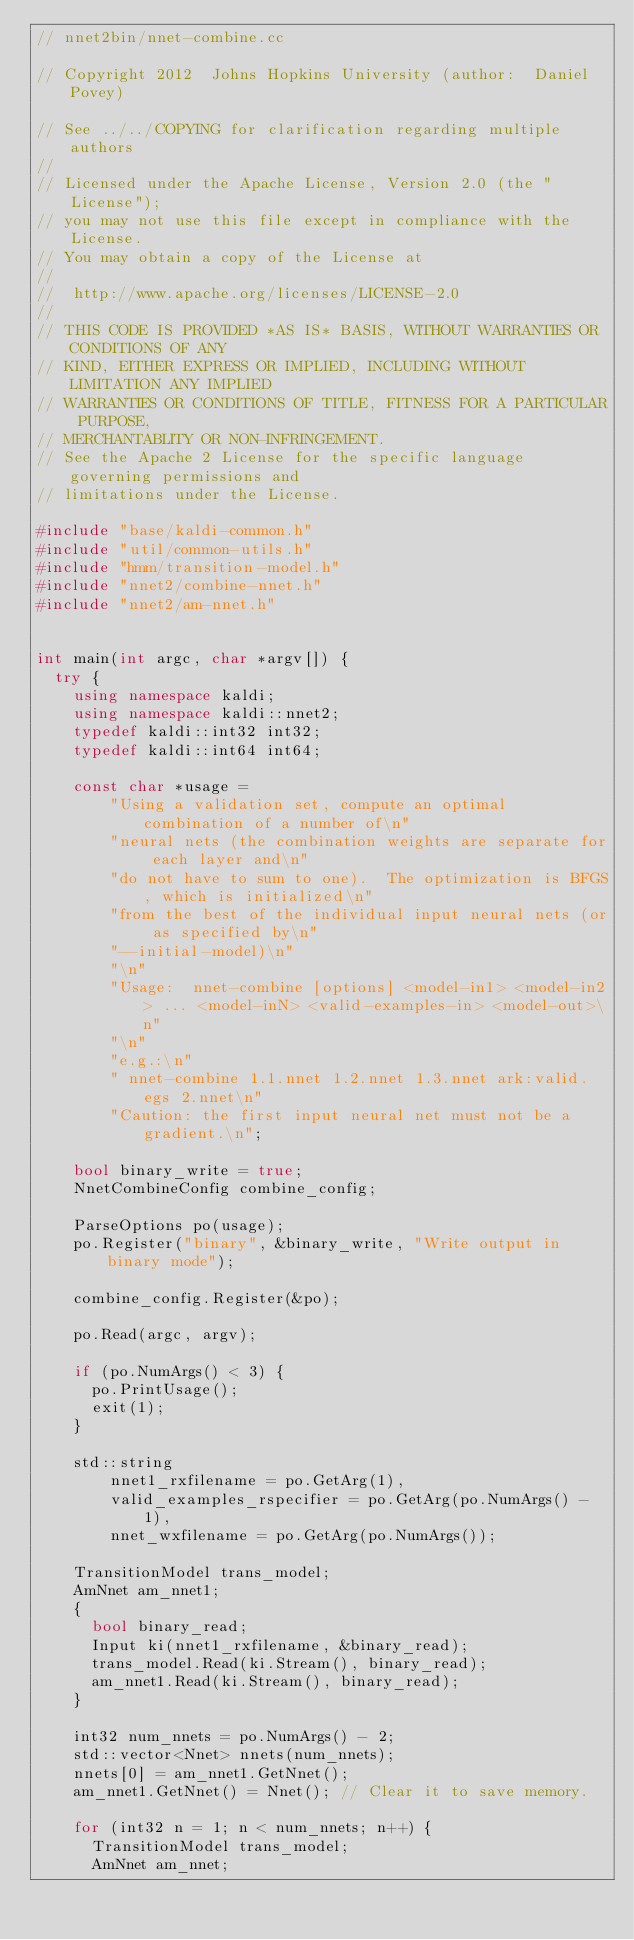Convert code to text. <code><loc_0><loc_0><loc_500><loc_500><_C++_>// nnet2bin/nnet-combine.cc

// Copyright 2012  Johns Hopkins University (author:  Daniel Povey)

// See ../../COPYING for clarification regarding multiple authors
//
// Licensed under the Apache License, Version 2.0 (the "License");
// you may not use this file except in compliance with the License.
// You may obtain a copy of the License at
//
//  http://www.apache.org/licenses/LICENSE-2.0
//
// THIS CODE IS PROVIDED *AS IS* BASIS, WITHOUT WARRANTIES OR CONDITIONS OF ANY
// KIND, EITHER EXPRESS OR IMPLIED, INCLUDING WITHOUT LIMITATION ANY IMPLIED
// WARRANTIES OR CONDITIONS OF TITLE, FITNESS FOR A PARTICULAR PURPOSE,
// MERCHANTABLITY OR NON-INFRINGEMENT.
// See the Apache 2 License for the specific language governing permissions and
// limitations under the License.

#include "base/kaldi-common.h"
#include "util/common-utils.h"
#include "hmm/transition-model.h"
#include "nnet2/combine-nnet.h"
#include "nnet2/am-nnet.h"


int main(int argc, char *argv[]) {
  try {
    using namespace kaldi;
    using namespace kaldi::nnet2;
    typedef kaldi::int32 int32;
    typedef kaldi::int64 int64;

    const char *usage =
        "Using a validation set, compute an optimal combination of a number of\n"
        "neural nets (the combination weights are separate for each layer and\n"
        "do not have to sum to one).  The optimization is BFGS, which is initialized\n"
        "from the best of the individual input neural nets (or as specified by\n"
        "--initial-model)\n"
        "\n"
        "Usage:  nnet-combine [options] <model-in1> <model-in2> ... <model-inN> <valid-examples-in> <model-out>\n"
        "\n"
        "e.g.:\n"
        " nnet-combine 1.1.nnet 1.2.nnet 1.3.nnet ark:valid.egs 2.nnet\n"
        "Caution: the first input neural net must not be a gradient.\n";
    
    bool binary_write = true;
    NnetCombineConfig combine_config;
    
    ParseOptions po(usage);
    po.Register("binary", &binary_write, "Write output in binary mode");
    
    combine_config.Register(&po);
    
    po.Read(argc, argv);
    
    if (po.NumArgs() < 3) {
      po.PrintUsage();
      exit(1);
    }
    
    std::string
        nnet1_rxfilename = po.GetArg(1),
        valid_examples_rspecifier = po.GetArg(po.NumArgs() - 1),
        nnet_wxfilename = po.GetArg(po.NumArgs());
    
    TransitionModel trans_model;
    AmNnet am_nnet1;
    {
      bool binary_read;
      Input ki(nnet1_rxfilename, &binary_read);
      trans_model.Read(ki.Stream(), binary_read);
      am_nnet1.Read(ki.Stream(), binary_read);
    }

    int32 num_nnets = po.NumArgs() - 2;
    std::vector<Nnet> nnets(num_nnets);
    nnets[0] = am_nnet1.GetNnet();
    am_nnet1.GetNnet() = Nnet(); // Clear it to save memory.

    for (int32 n = 1; n < num_nnets; n++) {
      TransitionModel trans_model;
      AmNnet am_nnet;</code> 